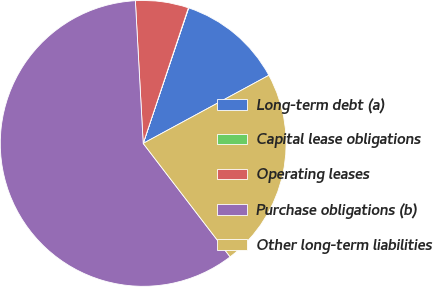Convert chart. <chart><loc_0><loc_0><loc_500><loc_500><pie_chart><fcel>Long-term debt (a)<fcel>Capital lease obligations<fcel>Operating leases<fcel>Purchase obligations (b)<fcel>Other long-term liabilities<nl><fcel>11.94%<fcel>0.04%<fcel>5.99%<fcel>59.53%<fcel>22.5%<nl></chart> 